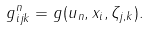Convert formula to latex. <formula><loc_0><loc_0><loc_500><loc_500>g ^ { n } _ { i j k } = g ( u _ { n } , x _ { i } , \zeta _ { j , k } ) .</formula> 